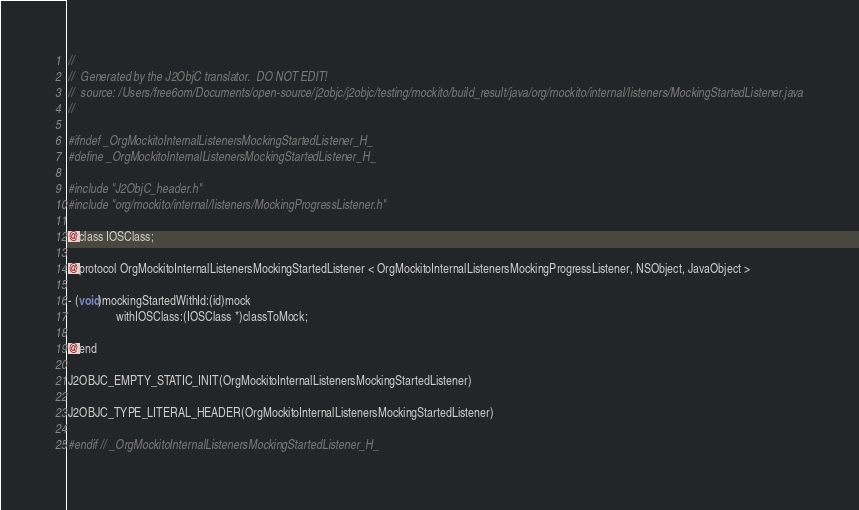Convert code to text. <code><loc_0><loc_0><loc_500><loc_500><_C_>//
//  Generated by the J2ObjC translator.  DO NOT EDIT!
//  source: /Users/free6om/Documents/open-source/j2objc/j2objc/testing/mockito/build_result/java/org/mockito/internal/listeners/MockingStartedListener.java
//

#ifndef _OrgMockitoInternalListenersMockingStartedListener_H_
#define _OrgMockitoInternalListenersMockingStartedListener_H_

#include "J2ObjC_header.h"
#include "org/mockito/internal/listeners/MockingProgressListener.h"

@class IOSClass;

@protocol OrgMockitoInternalListenersMockingStartedListener < OrgMockitoInternalListenersMockingProgressListener, NSObject, JavaObject >

- (void)mockingStartedWithId:(id)mock
                withIOSClass:(IOSClass *)classToMock;

@end

J2OBJC_EMPTY_STATIC_INIT(OrgMockitoInternalListenersMockingStartedListener)

J2OBJC_TYPE_LITERAL_HEADER(OrgMockitoInternalListenersMockingStartedListener)

#endif // _OrgMockitoInternalListenersMockingStartedListener_H_
</code> 